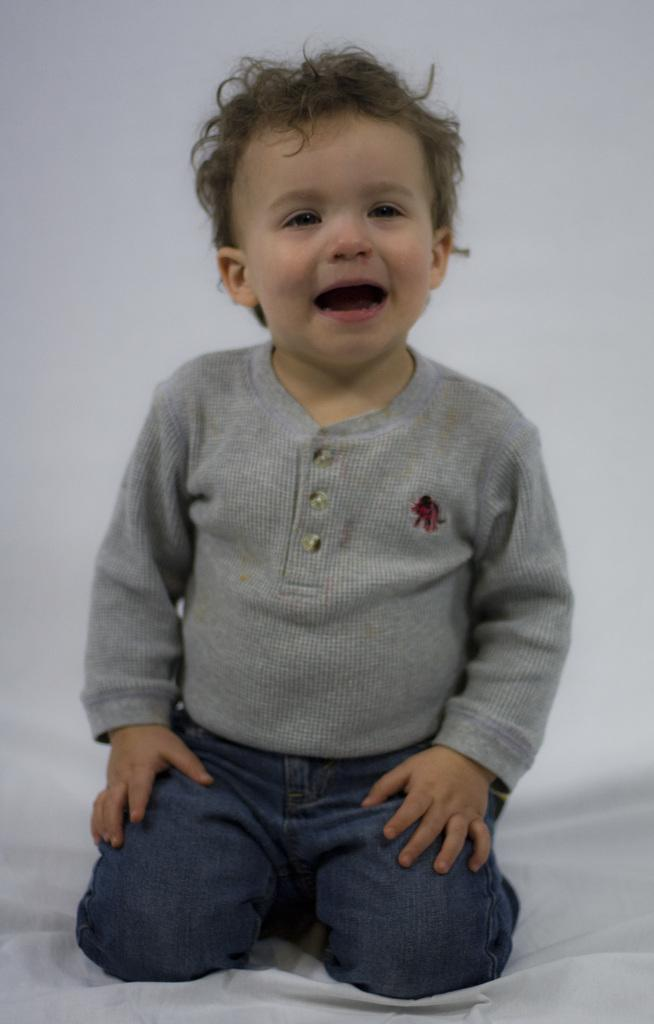What is the main subject of the image? The main subject of the image is a kid. What is the kid sitting on? The kid is sitting on a white color cloth. What can be seen in the background of the image? There is a white color wall in the background of the image. What type of oatmeal is the kid eating in the image? There is no oatmeal present in the image, and the kid is not eating anything. 